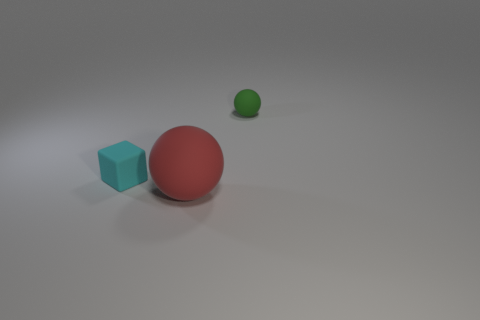How many red objects are made of the same material as the green thing?
Provide a succinct answer. 1. The sphere in front of the tiny matte object that is behind the tiny matte thing that is in front of the green ball is what color?
Make the answer very short. Red. Is the size of the red rubber thing the same as the cyan rubber thing?
Ensure brevity in your answer.  No. Is there any other thing that has the same shape as the tiny green rubber thing?
Keep it short and to the point. Yes. What number of objects are either balls that are in front of the small green matte sphere or big red objects?
Make the answer very short. 1. Do the tiny cyan object and the big object have the same shape?
Your response must be concise. No. How many other things are the same size as the green rubber sphere?
Provide a succinct answer. 1. What color is the large object?
Offer a very short reply. Red. What number of big things are either green things or balls?
Provide a succinct answer. 1. Is the size of the sphere that is in front of the tiny cyan rubber block the same as the rubber sphere that is behind the big thing?
Make the answer very short. No. 